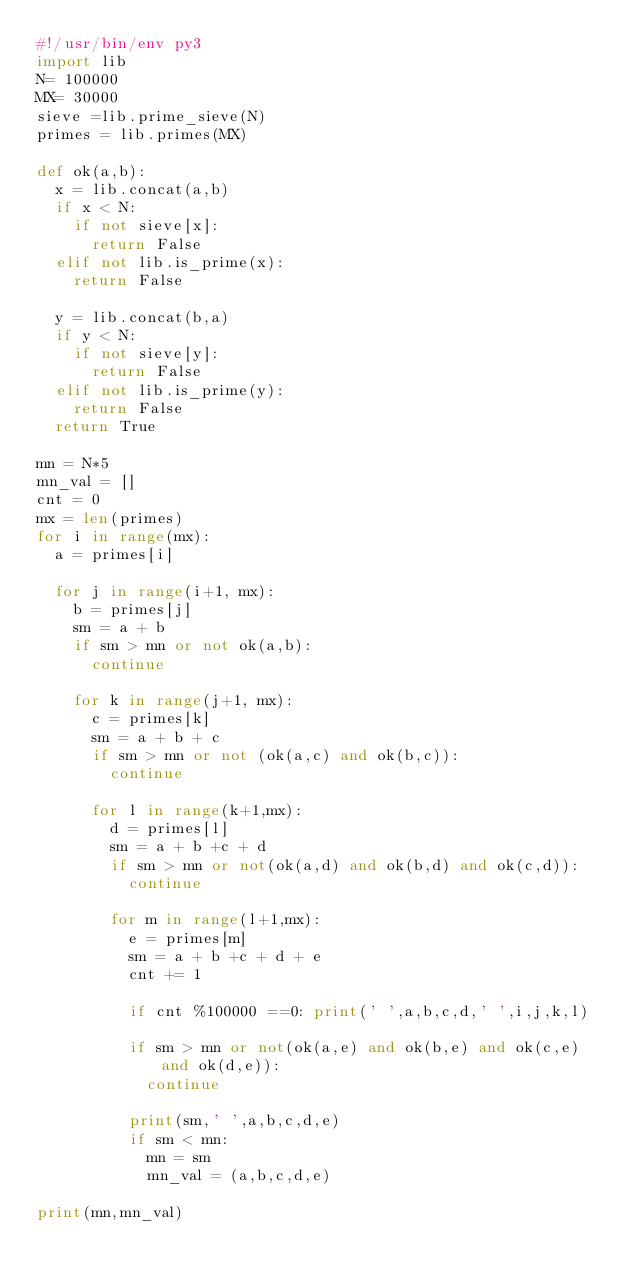Convert code to text. <code><loc_0><loc_0><loc_500><loc_500><_Python_>#!/usr/bin/env py3
import lib
N= 100000
MX= 30000
sieve =lib.prime_sieve(N)
primes = lib.primes(MX)

def ok(a,b):
  x = lib.concat(a,b)
  if x < N:
    if not sieve[x]:
      return False
  elif not lib.is_prime(x):
    return False

  y = lib.concat(b,a)
  if y < N:
    if not sieve[y]:
      return False
  elif not lib.is_prime(y):
    return False
  return True

mn = N*5
mn_val = []
cnt = 0
mx = len(primes)
for i in range(mx):
  a = primes[i]

  for j in range(i+1, mx):
    b = primes[j]
    sm = a + b
    if sm > mn or not ok(a,b):
      continue

    for k in range(j+1, mx):
      c = primes[k]
      sm = a + b + c
      if sm > mn or not (ok(a,c) and ok(b,c)):
        continue

      for l in range(k+1,mx):
        d = primes[l]
        sm = a + b +c + d
        if sm > mn or not(ok(a,d) and ok(b,d) and ok(c,d)):
          continue

        for m in range(l+1,mx):
          e = primes[m]
          sm = a + b +c + d + e
          cnt += 1

          if cnt %100000 ==0: print(' ',a,b,c,d,' ',i,j,k,l)
          
          if sm > mn or not(ok(a,e) and ok(b,e) and ok(c,e) and ok(d,e)):
            continue

          print(sm,' ',a,b,c,d,e)
          if sm < mn:
            mn = sm
            mn_val = (a,b,c,d,e)

print(mn,mn_val)


      
</code> 